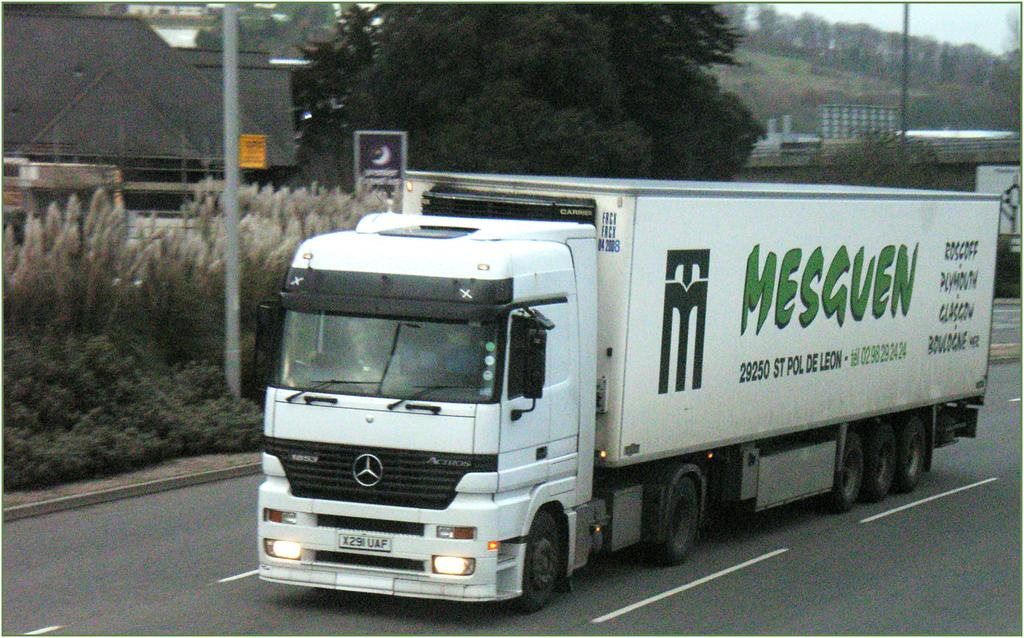What can be seen in the sky in the image? The sky is visible in the image. What type of natural vegetation is present in the image? There are trees and plants in the image. What man-made structures can be seen in the image? There are poles and boards in the image. What type of transportation is visible on the road in the image? There is a vehicle on the road in the image. What part of a house is visible on the left side of the image? The roof of a house is visible on the left side of the image. Can you see a list of items hanging from the cactus in the image? There is no cactus present in the image, and therefore no list of items hanging from it. 